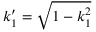Convert formula to latex. <formula><loc_0><loc_0><loc_500><loc_500>k _ { 1 } ^ { \prime } = \sqrt { 1 - k _ { 1 } ^ { 2 } }</formula> 